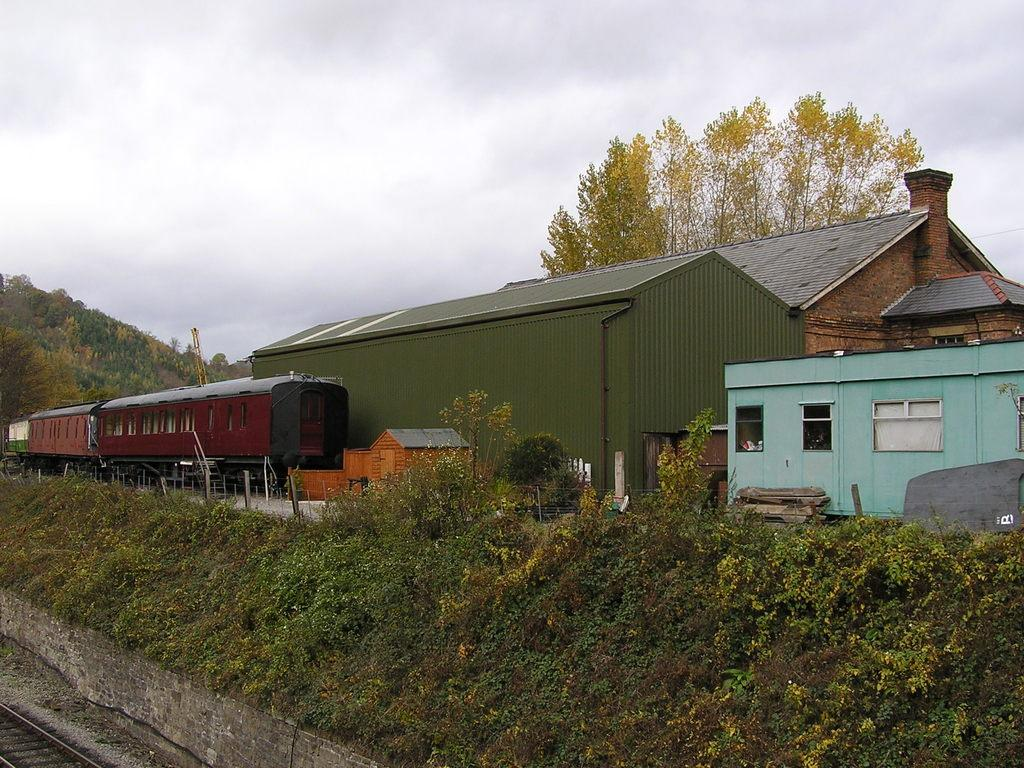What type of vegetation is located in the front of the image? There are plants in the front of the image. What is the main mode of transportation in the image? There is a train in the center of the image. What type of structures can be seen in the image? There are sheds in the image. What can be seen in the background of the image? There are trees in the background of the image. How would you describe the weather in the image? The sky is cloudy in the image. Is there any smoke coming from the train in the image? There is no mention of smoke in the provided facts, so we cannot determine if there is any smoke coming from the train. What type of precipitation can be seen falling from the clouds in the image? The provided facts do not mention any precipitation, so we cannot determine if there is any sleet falling from the clouds. 